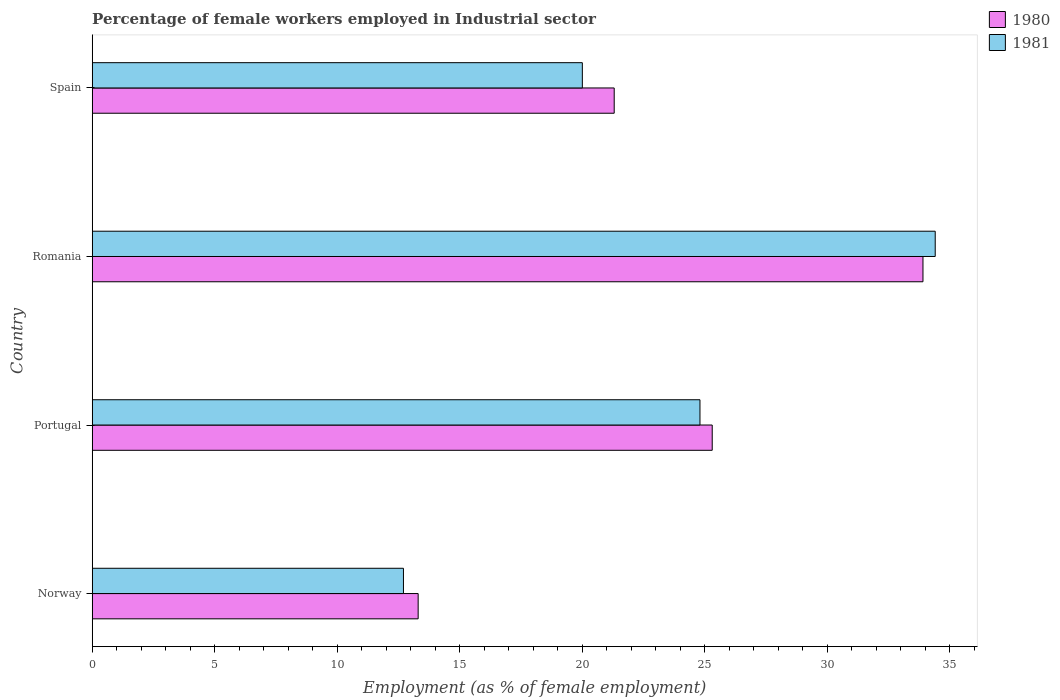How many different coloured bars are there?
Offer a terse response. 2. What is the label of the 1st group of bars from the top?
Keep it short and to the point. Spain. In how many cases, is the number of bars for a given country not equal to the number of legend labels?
Your answer should be compact. 0. What is the percentage of females employed in Industrial sector in 1981 in Spain?
Your answer should be very brief. 20. Across all countries, what is the maximum percentage of females employed in Industrial sector in 1981?
Provide a short and direct response. 34.4. Across all countries, what is the minimum percentage of females employed in Industrial sector in 1981?
Offer a terse response. 12.7. In which country was the percentage of females employed in Industrial sector in 1981 maximum?
Give a very brief answer. Romania. What is the total percentage of females employed in Industrial sector in 1981 in the graph?
Offer a very short reply. 91.9. What is the difference between the percentage of females employed in Industrial sector in 1981 in Norway and that in Spain?
Your answer should be very brief. -7.3. What is the difference between the percentage of females employed in Industrial sector in 1981 in Spain and the percentage of females employed in Industrial sector in 1980 in Portugal?
Keep it short and to the point. -5.3. What is the average percentage of females employed in Industrial sector in 1981 per country?
Provide a succinct answer. 22.98. What is the difference between the percentage of females employed in Industrial sector in 1981 and percentage of females employed in Industrial sector in 1980 in Spain?
Your response must be concise. -1.3. What is the ratio of the percentage of females employed in Industrial sector in 1980 in Portugal to that in Spain?
Make the answer very short. 1.19. What is the difference between the highest and the second highest percentage of females employed in Industrial sector in 1981?
Your answer should be compact. 9.6. What is the difference between the highest and the lowest percentage of females employed in Industrial sector in 1981?
Offer a very short reply. 21.7. Is the sum of the percentage of females employed in Industrial sector in 1981 in Portugal and Romania greater than the maximum percentage of females employed in Industrial sector in 1980 across all countries?
Keep it short and to the point. Yes. What does the 1st bar from the top in Romania represents?
Offer a terse response. 1981. What does the 2nd bar from the bottom in Spain represents?
Offer a terse response. 1981. How many countries are there in the graph?
Your response must be concise. 4. What is the difference between two consecutive major ticks on the X-axis?
Provide a short and direct response. 5. Does the graph contain any zero values?
Provide a succinct answer. No. Where does the legend appear in the graph?
Give a very brief answer. Top right. What is the title of the graph?
Your answer should be very brief. Percentage of female workers employed in Industrial sector. What is the label or title of the X-axis?
Give a very brief answer. Employment (as % of female employment). What is the Employment (as % of female employment) in 1980 in Norway?
Make the answer very short. 13.3. What is the Employment (as % of female employment) of 1981 in Norway?
Make the answer very short. 12.7. What is the Employment (as % of female employment) in 1980 in Portugal?
Ensure brevity in your answer.  25.3. What is the Employment (as % of female employment) in 1981 in Portugal?
Provide a succinct answer. 24.8. What is the Employment (as % of female employment) in 1980 in Romania?
Give a very brief answer. 33.9. What is the Employment (as % of female employment) of 1981 in Romania?
Your answer should be compact. 34.4. What is the Employment (as % of female employment) in 1980 in Spain?
Offer a terse response. 21.3. What is the Employment (as % of female employment) in 1981 in Spain?
Give a very brief answer. 20. Across all countries, what is the maximum Employment (as % of female employment) of 1980?
Your response must be concise. 33.9. Across all countries, what is the maximum Employment (as % of female employment) of 1981?
Your answer should be compact. 34.4. Across all countries, what is the minimum Employment (as % of female employment) of 1980?
Provide a succinct answer. 13.3. Across all countries, what is the minimum Employment (as % of female employment) in 1981?
Give a very brief answer. 12.7. What is the total Employment (as % of female employment) in 1980 in the graph?
Offer a terse response. 93.8. What is the total Employment (as % of female employment) of 1981 in the graph?
Give a very brief answer. 91.9. What is the difference between the Employment (as % of female employment) of 1980 in Norway and that in Romania?
Your response must be concise. -20.6. What is the difference between the Employment (as % of female employment) in 1981 in Norway and that in Romania?
Ensure brevity in your answer.  -21.7. What is the difference between the Employment (as % of female employment) of 1980 in Norway and that in Spain?
Give a very brief answer. -8. What is the difference between the Employment (as % of female employment) of 1980 in Portugal and that in Romania?
Your response must be concise. -8.6. What is the difference between the Employment (as % of female employment) in 1980 in Portugal and that in Spain?
Ensure brevity in your answer.  4. What is the difference between the Employment (as % of female employment) in 1981 in Portugal and that in Spain?
Your response must be concise. 4.8. What is the difference between the Employment (as % of female employment) of 1980 in Romania and that in Spain?
Give a very brief answer. 12.6. What is the difference between the Employment (as % of female employment) in 1980 in Norway and the Employment (as % of female employment) in 1981 in Portugal?
Your response must be concise. -11.5. What is the difference between the Employment (as % of female employment) of 1980 in Norway and the Employment (as % of female employment) of 1981 in Romania?
Provide a succinct answer. -21.1. What is the difference between the Employment (as % of female employment) in 1980 in Portugal and the Employment (as % of female employment) in 1981 in Romania?
Offer a terse response. -9.1. What is the difference between the Employment (as % of female employment) in 1980 in Portugal and the Employment (as % of female employment) in 1981 in Spain?
Make the answer very short. 5.3. What is the difference between the Employment (as % of female employment) in 1980 in Romania and the Employment (as % of female employment) in 1981 in Spain?
Your answer should be compact. 13.9. What is the average Employment (as % of female employment) of 1980 per country?
Your answer should be compact. 23.45. What is the average Employment (as % of female employment) of 1981 per country?
Offer a very short reply. 22.98. What is the difference between the Employment (as % of female employment) in 1980 and Employment (as % of female employment) in 1981 in Norway?
Offer a terse response. 0.6. What is the difference between the Employment (as % of female employment) of 1980 and Employment (as % of female employment) of 1981 in Portugal?
Ensure brevity in your answer.  0.5. What is the difference between the Employment (as % of female employment) in 1980 and Employment (as % of female employment) in 1981 in Romania?
Offer a very short reply. -0.5. What is the difference between the Employment (as % of female employment) of 1980 and Employment (as % of female employment) of 1981 in Spain?
Provide a short and direct response. 1.3. What is the ratio of the Employment (as % of female employment) in 1980 in Norway to that in Portugal?
Offer a terse response. 0.53. What is the ratio of the Employment (as % of female employment) in 1981 in Norway to that in Portugal?
Offer a very short reply. 0.51. What is the ratio of the Employment (as % of female employment) of 1980 in Norway to that in Romania?
Provide a succinct answer. 0.39. What is the ratio of the Employment (as % of female employment) in 1981 in Norway to that in Romania?
Keep it short and to the point. 0.37. What is the ratio of the Employment (as % of female employment) in 1980 in Norway to that in Spain?
Your response must be concise. 0.62. What is the ratio of the Employment (as % of female employment) of 1981 in Norway to that in Spain?
Keep it short and to the point. 0.64. What is the ratio of the Employment (as % of female employment) in 1980 in Portugal to that in Romania?
Make the answer very short. 0.75. What is the ratio of the Employment (as % of female employment) in 1981 in Portugal to that in Romania?
Make the answer very short. 0.72. What is the ratio of the Employment (as % of female employment) of 1980 in Portugal to that in Spain?
Provide a succinct answer. 1.19. What is the ratio of the Employment (as % of female employment) of 1981 in Portugal to that in Spain?
Provide a short and direct response. 1.24. What is the ratio of the Employment (as % of female employment) in 1980 in Romania to that in Spain?
Your answer should be very brief. 1.59. What is the ratio of the Employment (as % of female employment) of 1981 in Romania to that in Spain?
Your answer should be very brief. 1.72. What is the difference between the highest and the second highest Employment (as % of female employment) of 1981?
Offer a terse response. 9.6. What is the difference between the highest and the lowest Employment (as % of female employment) of 1980?
Offer a terse response. 20.6. What is the difference between the highest and the lowest Employment (as % of female employment) in 1981?
Offer a very short reply. 21.7. 